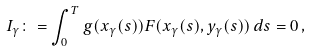<formula> <loc_0><loc_0><loc_500><loc_500>I _ { \gamma } \colon = \int _ { 0 } ^ { T } g ( x _ { \gamma } ( s ) ) F ( x _ { \gamma } ( s ) , y _ { \gamma } ( s ) ) \, d s = 0 \, ,</formula> 